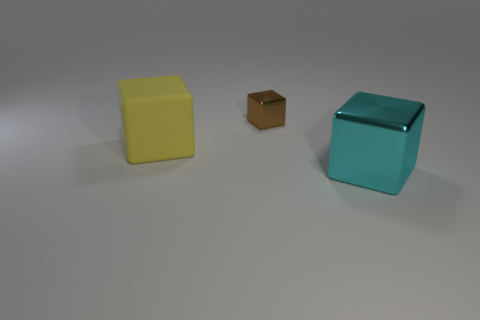Is the number of cyan cubes left of the cyan metallic cube the same as the number of tiny green metallic cylinders? yes 